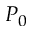<formula> <loc_0><loc_0><loc_500><loc_500>P _ { 0 }</formula> 